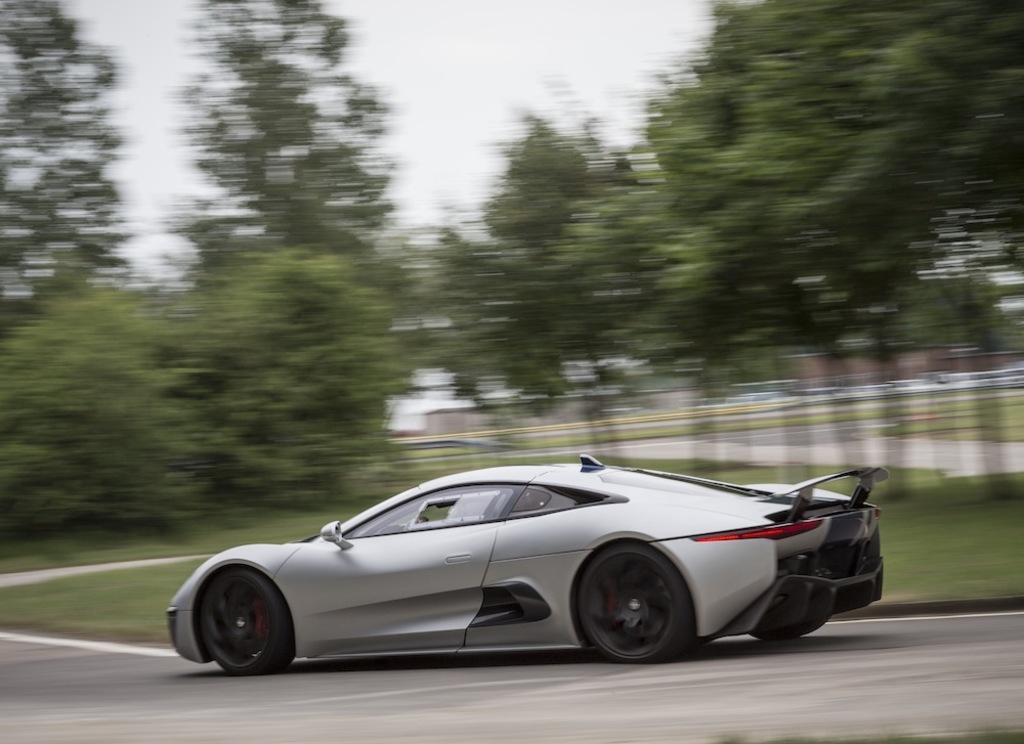What is the main subject of the image? The main subject of the image is a car. Where is the car located in the image? The car is on the road in the image. What is the car doing in the image? The car is passing in the image. What can be seen behind the car in the image? There are trees and buildings behind the car in the image. Can you tell me who won the argument between the girl and the car in the image? There is no girl or argument present in the image; it only features a car on the road. 